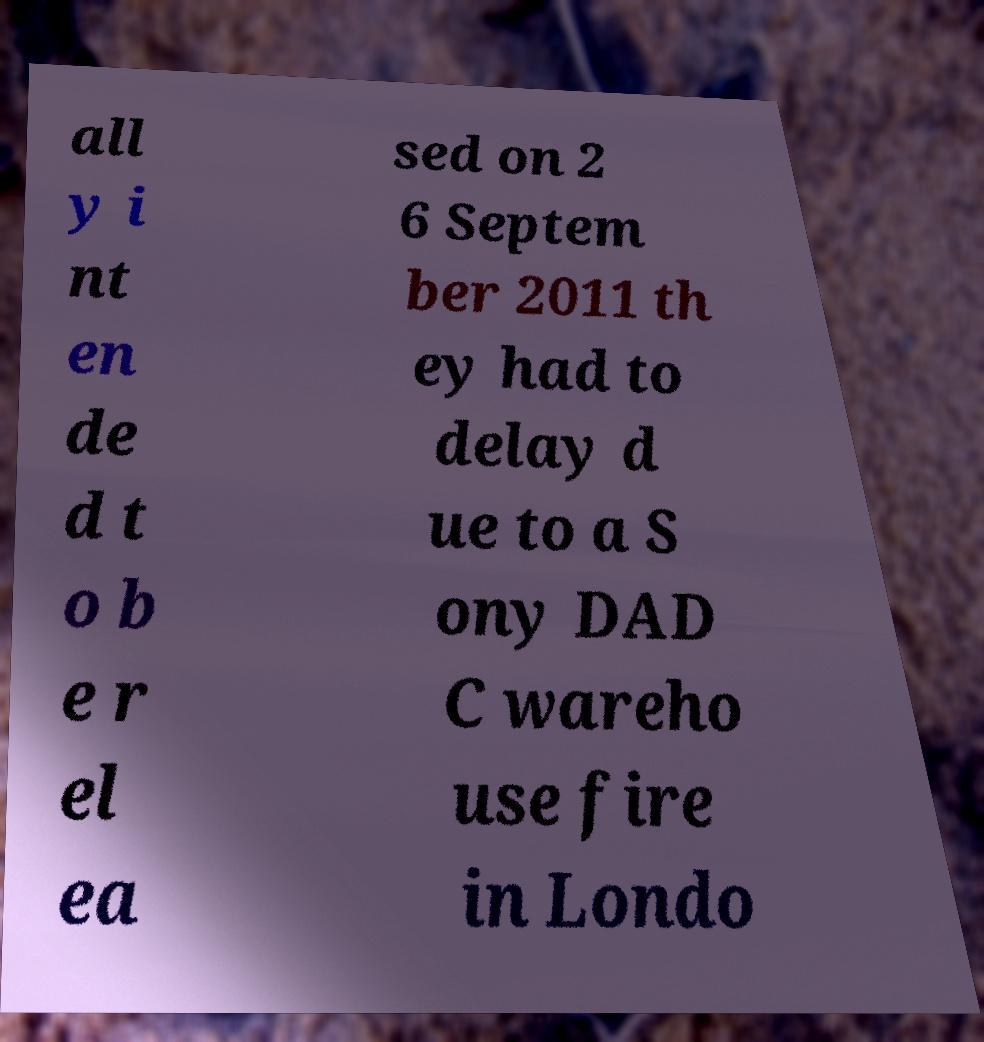There's text embedded in this image that I need extracted. Can you transcribe it verbatim? all y i nt en de d t o b e r el ea sed on 2 6 Septem ber 2011 th ey had to delay d ue to a S ony DAD C wareho use fire in Londo 